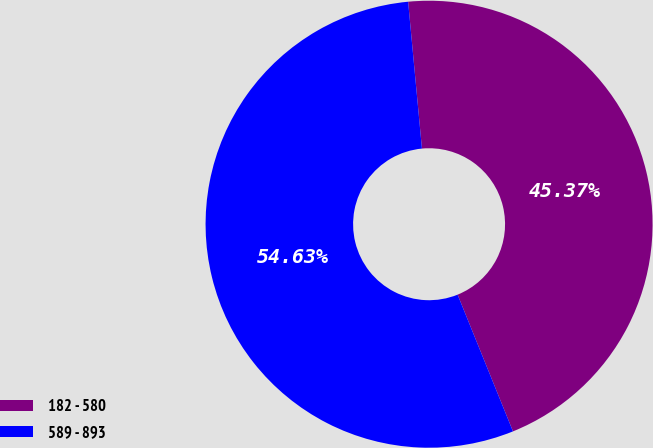Convert chart. <chart><loc_0><loc_0><loc_500><loc_500><pie_chart><fcel>182 - 580<fcel>589 - 893<nl><fcel>45.37%<fcel>54.63%<nl></chart> 